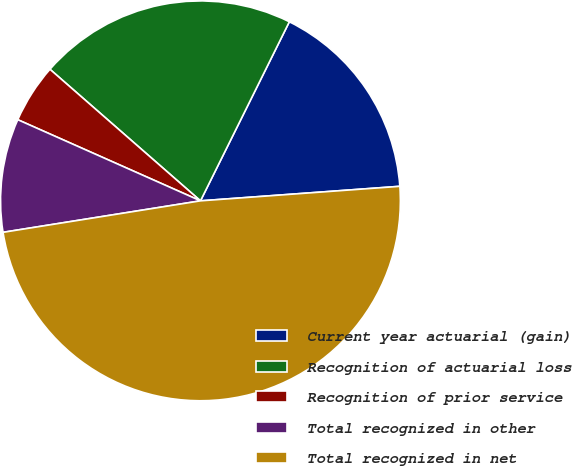Convert chart to OTSL. <chart><loc_0><loc_0><loc_500><loc_500><pie_chart><fcel>Current year actuarial (gain)<fcel>Recognition of actuarial loss<fcel>Recognition of prior service<fcel>Total recognized in other<fcel>Total recognized in net<nl><fcel>16.51%<fcel>20.9%<fcel>4.78%<fcel>9.17%<fcel>48.64%<nl></chart> 